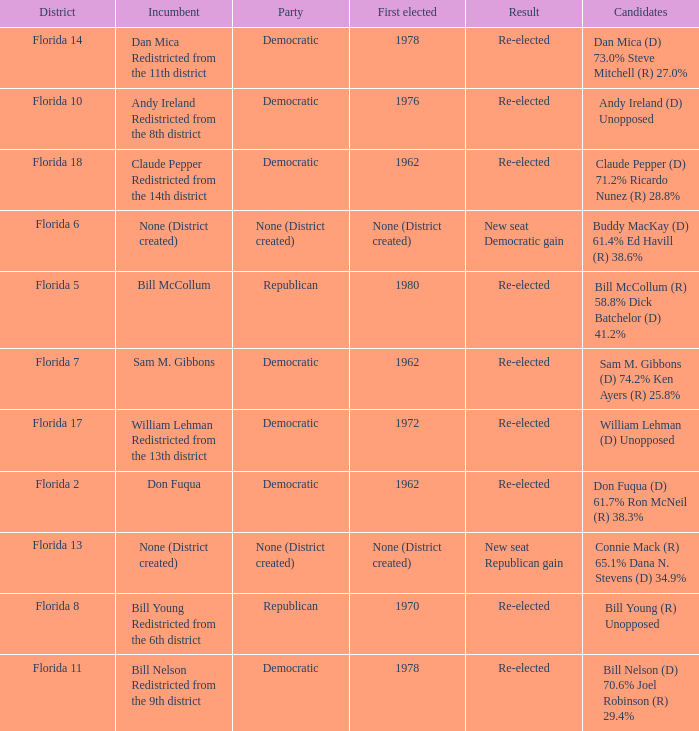Who is the the candidates with incumbent being don fuqua Don Fuqua (D) 61.7% Ron McNeil (R) 38.3%. 